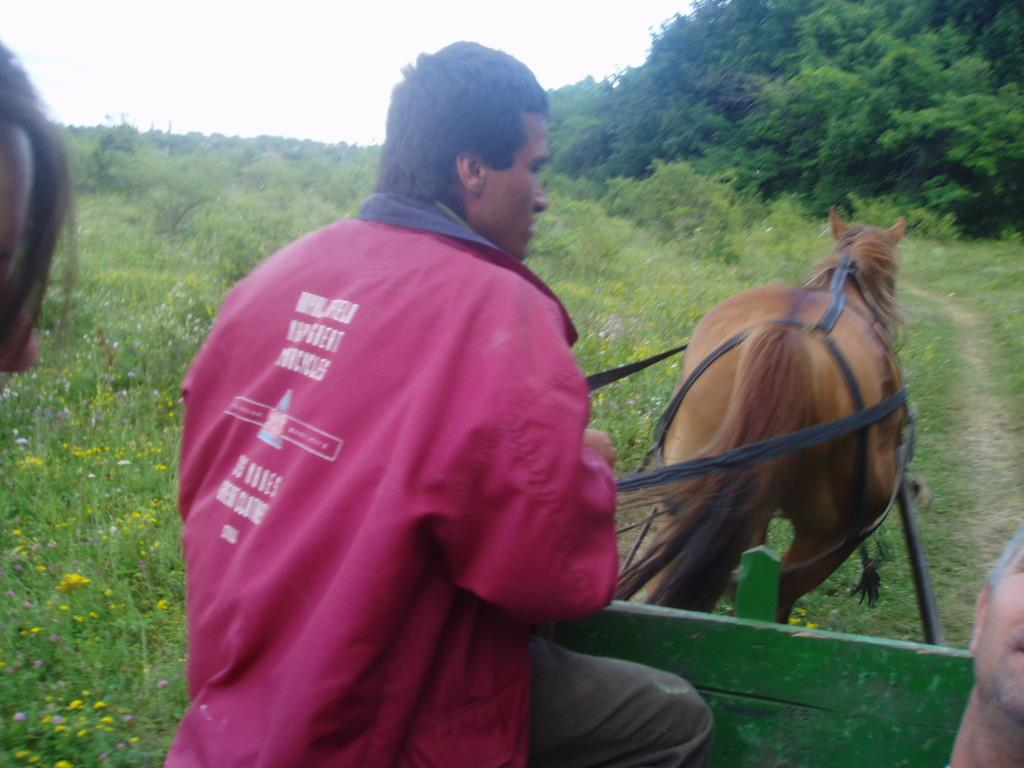Who is present in the image? There is a man in the image. What is the man wearing? The man is wearing a pink jacket. What is the man doing in the image? The man is sitting on a cart and riding a horse. What can be seen in front of the man? There are trees in front of the man. What type of vegetation is visible to the left side of the image? There is grass to the left side of the image. How many rabbits are hopping around the man in the image? There are no rabbits present in the image. What type of plot is the man cultivating in the image? There is no plot or cultivation activity depicted in the image. 